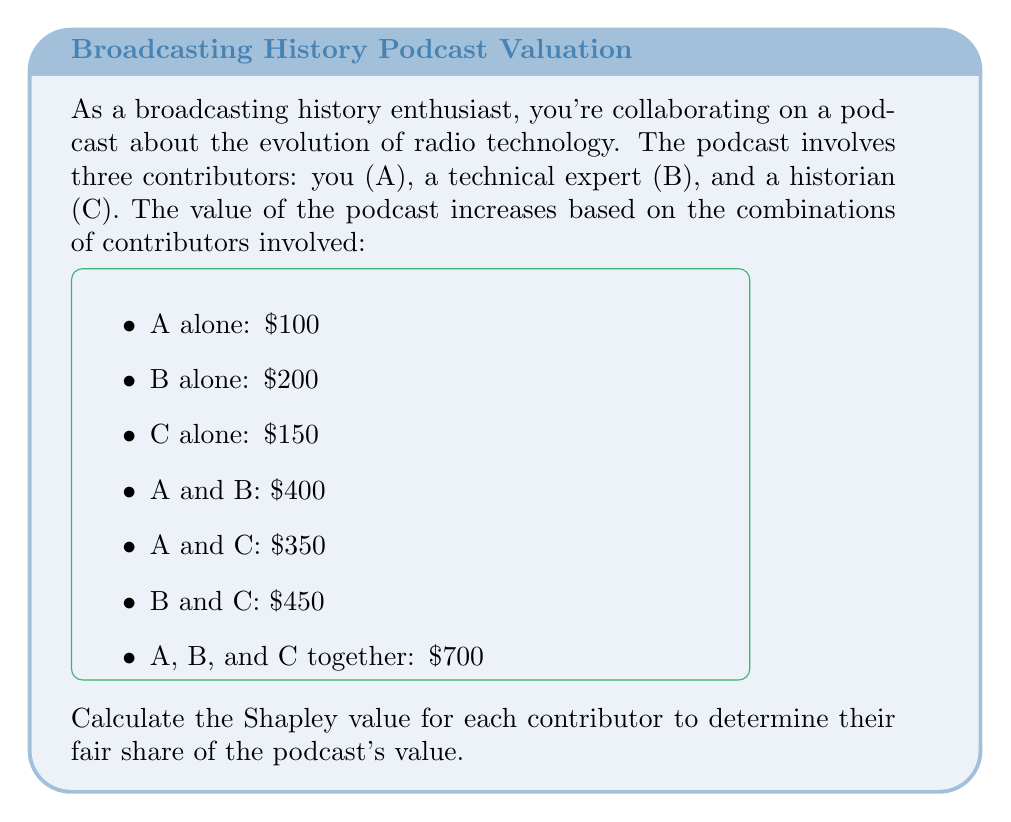Solve this math problem. To calculate the Shapley value, we need to determine each contributor's marginal contribution in all possible orderings:

1. List all possible orderings:
   ABC, ACB, BAC, BCA, CAB, CBA

2. Calculate marginal contributions for each ordering:

   ABC: A=$100, B=$300, C=$300
   ACB: A=$100, C=$250, B=$350
   BAC: B=$200, A=$200, C=$300
   BCA: B=$200, C=$250, A=$250
   CAB: C=$150, A=$200, B=$350
   CBA: C=$150, B=$300, A=$250

3. Sum up the marginal contributions for each contributor:
   A: $100 + $100 + $200 + $250 + $200 + $250 = $1100
   B: $300 + $350 + $200 + $200 + $350 + $300 = $1700
   C: $300 + $250 + $300 + $250 + $150 + $150 = $1400

4. Divide each sum by the number of orderings (6) to get the Shapley value:

   Shapley value for A: $\frac{1100}{6} = 183.33$
   Shapley value for B: $\frac{1700}{6} = 283.33$
   Shapley value for C: $\frac{1400}{6} = 233.33$

5. Verify that the sum of Shapley values equals the total value:
   $183.33 + 283.33 + 233.33 = 699.99 \approx 700$
Answer: A: $183.33, B: $283.33, C: $233.33 